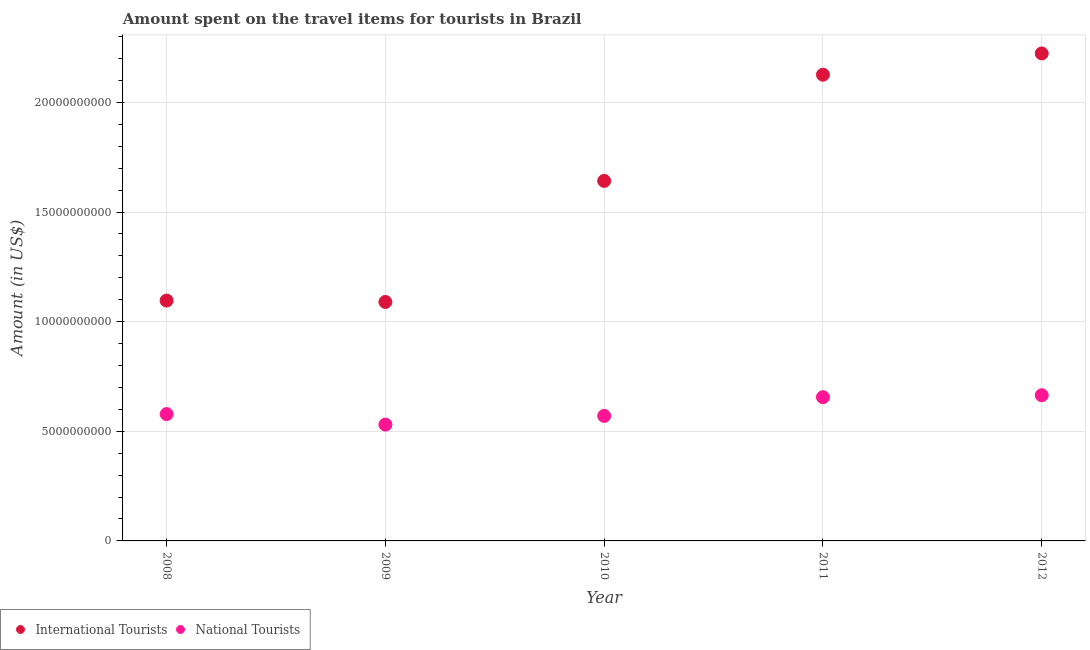Is the number of dotlines equal to the number of legend labels?
Your answer should be compact. Yes. What is the amount spent on travel items of international tourists in 2012?
Ensure brevity in your answer.  2.22e+1. Across all years, what is the maximum amount spent on travel items of international tourists?
Provide a succinct answer. 2.22e+1. Across all years, what is the minimum amount spent on travel items of international tourists?
Your answer should be very brief. 1.09e+1. In which year was the amount spent on travel items of international tourists maximum?
Ensure brevity in your answer.  2012. In which year was the amount spent on travel items of national tourists minimum?
Provide a succinct answer. 2009. What is the total amount spent on travel items of international tourists in the graph?
Give a very brief answer. 8.18e+1. What is the difference between the amount spent on travel items of national tourists in 2010 and that in 2012?
Make the answer very short. -9.43e+08. What is the difference between the amount spent on travel items of international tourists in 2011 and the amount spent on travel items of national tourists in 2008?
Your answer should be compact. 1.55e+1. What is the average amount spent on travel items of international tourists per year?
Offer a very short reply. 1.64e+1. In the year 2009, what is the difference between the amount spent on travel items of national tourists and amount spent on travel items of international tourists?
Your answer should be very brief. -5.59e+09. What is the ratio of the amount spent on travel items of national tourists in 2008 to that in 2009?
Your answer should be very brief. 1.09. Is the difference between the amount spent on travel items of national tourists in 2009 and 2012 greater than the difference between the amount spent on travel items of international tourists in 2009 and 2012?
Keep it short and to the point. Yes. What is the difference between the highest and the second highest amount spent on travel items of national tourists?
Your answer should be compact. 9.00e+07. What is the difference between the highest and the lowest amount spent on travel items of national tourists?
Your response must be concise. 1.34e+09. In how many years, is the amount spent on travel items of national tourists greater than the average amount spent on travel items of national tourists taken over all years?
Offer a terse response. 2. Is the amount spent on travel items of national tourists strictly less than the amount spent on travel items of international tourists over the years?
Offer a terse response. Yes. How many years are there in the graph?
Your response must be concise. 5. What is the difference between two consecutive major ticks on the Y-axis?
Your answer should be very brief. 5.00e+09. Are the values on the major ticks of Y-axis written in scientific E-notation?
Keep it short and to the point. No. Does the graph contain any zero values?
Your answer should be compact. No. Where does the legend appear in the graph?
Give a very brief answer. Bottom left. How many legend labels are there?
Give a very brief answer. 2. How are the legend labels stacked?
Keep it short and to the point. Horizontal. What is the title of the graph?
Your answer should be compact. Amount spent on the travel items for tourists in Brazil. Does "Rural Population" appear as one of the legend labels in the graph?
Give a very brief answer. No. What is the label or title of the X-axis?
Provide a succinct answer. Year. What is the Amount (in US$) in International Tourists in 2008?
Make the answer very short. 1.10e+1. What is the Amount (in US$) in National Tourists in 2008?
Your answer should be compact. 5.78e+09. What is the Amount (in US$) in International Tourists in 2009?
Provide a succinct answer. 1.09e+1. What is the Amount (in US$) in National Tourists in 2009?
Offer a very short reply. 5.30e+09. What is the Amount (in US$) in International Tourists in 2010?
Offer a terse response. 1.64e+1. What is the Amount (in US$) of National Tourists in 2010?
Make the answer very short. 5.70e+09. What is the Amount (in US$) of International Tourists in 2011?
Your answer should be very brief. 2.13e+1. What is the Amount (in US$) in National Tourists in 2011?
Make the answer very short. 6.56e+09. What is the Amount (in US$) of International Tourists in 2012?
Offer a terse response. 2.22e+1. What is the Amount (in US$) of National Tourists in 2012?
Provide a short and direct response. 6.64e+09. Across all years, what is the maximum Amount (in US$) of International Tourists?
Give a very brief answer. 2.22e+1. Across all years, what is the maximum Amount (in US$) of National Tourists?
Your answer should be very brief. 6.64e+09. Across all years, what is the minimum Amount (in US$) in International Tourists?
Your answer should be very brief. 1.09e+1. Across all years, what is the minimum Amount (in US$) in National Tourists?
Your answer should be very brief. 5.30e+09. What is the total Amount (in US$) in International Tourists in the graph?
Make the answer very short. 8.18e+1. What is the total Amount (in US$) of National Tourists in the graph?
Your answer should be compact. 3.00e+1. What is the difference between the Amount (in US$) of International Tourists in 2008 and that in 2009?
Your answer should be compact. 6.40e+07. What is the difference between the Amount (in US$) in National Tourists in 2008 and that in 2009?
Make the answer very short. 4.80e+08. What is the difference between the Amount (in US$) in International Tourists in 2008 and that in 2010?
Provide a short and direct response. -5.46e+09. What is the difference between the Amount (in US$) in National Tourists in 2008 and that in 2010?
Provide a short and direct response. 8.30e+07. What is the difference between the Amount (in US$) in International Tourists in 2008 and that in 2011?
Make the answer very short. -1.03e+1. What is the difference between the Amount (in US$) in National Tourists in 2008 and that in 2011?
Your answer should be very brief. -7.70e+08. What is the difference between the Amount (in US$) of International Tourists in 2008 and that in 2012?
Your answer should be compact. -1.13e+1. What is the difference between the Amount (in US$) of National Tourists in 2008 and that in 2012?
Your answer should be compact. -8.60e+08. What is the difference between the Amount (in US$) in International Tourists in 2009 and that in 2010?
Provide a succinct answer. -5.52e+09. What is the difference between the Amount (in US$) of National Tourists in 2009 and that in 2010?
Offer a very short reply. -3.97e+08. What is the difference between the Amount (in US$) of International Tourists in 2009 and that in 2011?
Your answer should be compact. -1.04e+1. What is the difference between the Amount (in US$) of National Tourists in 2009 and that in 2011?
Your answer should be compact. -1.25e+09. What is the difference between the Amount (in US$) of International Tourists in 2009 and that in 2012?
Provide a short and direct response. -1.13e+1. What is the difference between the Amount (in US$) in National Tourists in 2009 and that in 2012?
Your response must be concise. -1.34e+09. What is the difference between the Amount (in US$) in International Tourists in 2010 and that in 2011?
Provide a succinct answer. -4.84e+09. What is the difference between the Amount (in US$) in National Tourists in 2010 and that in 2011?
Offer a very short reply. -8.53e+08. What is the difference between the Amount (in US$) in International Tourists in 2010 and that in 2012?
Keep it short and to the point. -5.81e+09. What is the difference between the Amount (in US$) in National Tourists in 2010 and that in 2012?
Make the answer very short. -9.43e+08. What is the difference between the Amount (in US$) of International Tourists in 2011 and that in 2012?
Make the answer very short. -9.69e+08. What is the difference between the Amount (in US$) of National Tourists in 2011 and that in 2012?
Your answer should be compact. -9.00e+07. What is the difference between the Amount (in US$) in International Tourists in 2008 and the Amount (in US$) in National Tourists in 2009?
Provide a short and direct response. 5.66e+09. What is the difference between the Amount (in US$) of International Tourists in 2008 and the Amount (in US$) of National Tourists in 2010?
Provide a succinct answer. 5.26e+09. What is the difference between the Amount (in US$) of International Tourists in 2008 and the Amount (in US$) of National Tourists in 2011?
Provide a short and direct response. 4.41e+09. What is the difference between the Amount (in US$) of International Tourists in 2008 and the Amount (in US$) of National Tourists in 2012?
Give a very brief answer. 4.32e+09. What is the difference between the Amount (in US$) of International Tourists in 2009 and the Amount (in US$) of National Tourists in 2010?
Offer a terse response. 5.20e+09. What is the difference between the Amount (in US$) in International Tourists in 2009 and the Amount (in US$) in National Tourists in 2011?
Offer a very short reply. 4.34e+09. What is the difference between the Amount (in US$) of International Tourists in 2009 and the Amount (in US$) of National Tourists in 2012?
Offer a terse response. 4.25e+09. What is the difference between the Amount (in US$) in International Tourists in 2010 and the Amount (in US$) in National Tourists in 2011?
Your response must be concise. 9.86e+09. What is the difference between the Amount (in US$) in International Tourists in 2010 and the Amount (in US$) in National Tourists in 2012?
Your response must be concise. 9.78e+09. What is the difference between the Amount (in US$) of International Tourists in 2011 and the Amount (in US$) of National Tourists in 2012?
Make the answer very short. 1.46e+1. What is the average Amount (in US$) in International Tourists per year?
Provide a short and direct response. 1.64e+1. What is the average Amount (in US$) in National Tourists per year?
Provide a succinct answer. 6.00e+09. In the year 2008, what is the difference between the Amount (in US$) in International Tourists and Amount (in US$) in National Tourists?
Your response must be concise. 5.18e+09. In the year 2009, what is the difference between the Amount (in US$) in International Tourists and Amount (in US$) in National Tourists?
Your answer should be very brief. 5.59e+09. In the year 2010, what is the difference between the Amount (in US$) in International Tourists and Amount (in US$) in National Tourists?
Your answer should be compact. 1.07e+1. In the year 2011, what is the difference between the Amount (in US$) in International Tourists and Amount (in US$) in National Tourists?
Make the answer very short. 1.47e+1. In the year 2012, what is the difference between the Amount (in US$) of International Tourists and Amount (in US$) of National Tourists?
Ensure brevity in your answer.  1.56e+1. What is the ratio of the Amount (in US$) in International Tourists in 2008 to that in 2009?
Keep it short and to the point. 1.01. What is the ratio of the Amount (in US$) of National Tourists in 2008 to that in 2009?
Your response must be concise. 1.09. What is the ratio of the Amount (in US$) of International Tourists in 2008 to that in 2010?
Your answer should be compact. 0.67. What is the ratio of the Amount (in US$) in National Tourists in 2008 to that in 2010?
Offer a terse response. 1.01. What is the ratio of the Amount (in US$) in International Tourists in 2008 to that in 2011?
Offer a very short reply. 0.52. What is the ratio of the Amount (in US$) in National Tourists in 2008 to that in 2011?
Keep it short and to the point. 0.88. What is the ratio of the Amount (in US$) of International Tourists in 2008 to that in 2012?
Give a very brief answer. 0.49. What is the ratio of the Amount (in US$) in National Tourists in 2008 to that in 2012?
Ensure brevity in your answer.  0.87. What is the ratio of the Amount (in US$) in International Tourists in 2009 to that in 2010?
Provide a short and direct response. 0.66. What is the ratio of the Amount (in US$) of National Tourists in 2009 to that in 2010?
Give a very brief answer. 0.93. What is the ratio of the Amount (in US$) of International Tourists in 2009 to that in 2011?
Provide a short and direct response. 0.51. What is the ratio of the Amount (in US$) in National Tourists in 2009 to that in 2011?
Offer a terse response. 0.81. What is the ratio of the Amount (in US$) of International Tourists in 2009 to that in 2012?
Your answer should be very brief. 0.49. What is the ratio of the Amount (in US$) in National Tourists in 2009 to that in 2012?
Offer a terse response. 0.8. What is the ratio of the Amount (in US$) in International Tourists in 2010 to that in 2011?
Provide a short and direct response. 0.77. What is the ratio of the Amount (in US$) in National Tourists in 2010 to that in 2011?
Ensure brevity in your answer.  0.87. What is the ratio of the Amount (in US$) in International Tourists in 2010 to that in 2012?
Your answer should be very brief. 0.74. What is the ratio of the Amount (in US$) in National Tourists in 2010 to that in 2012?
Ensure brevity in your answer.  0.86. What is the ratio of the Amount (in US$) of International Tourists in 2011 to that in 2012?
Your response must be concise. 0.96. What is the ratio of the Amount (in US$) of National Tourists in 2011 to that in 2012?
Your response must be concise. 0.99. What is the difference between the highest and the second highest Amount (in US$) in International Tourists?
Your response must be concise. 9.69e+08. What is the difference between the highest and the second highest Amount (in US$) of National Tourists?
Make the answer very short. 9.00e+07. What is the difference between the highest and the lowest Amount (in US$) in International Tourists?
Your answer should be very brief. 1.13e+1. What is the difference between the highest and the lowest Amount (in US$) in National Tourists?
Ensure brevity in your answer.  1.34e+09. 